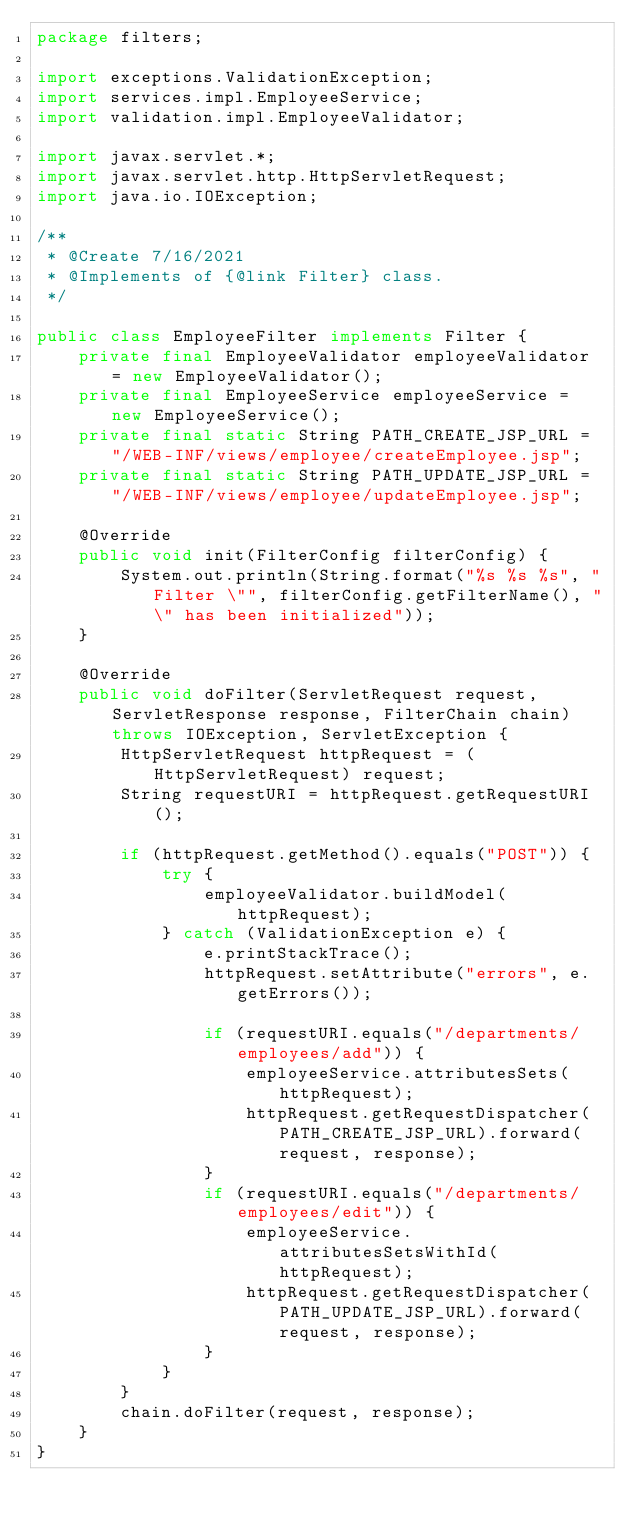<code> <loc_0><loc_0><loc_500><loc_500><_Java_>package filters;

import exceptions.ValidationException;
import services.impl.EmployeeService;
import validation.impl.EmployeeValidator;

import javax.servlet.*;
import javax.servlet.http.HttpServletRequest;
import java.io.IOException;

/**
 * @Create 7/16/2021
 * @Implements of {@link Filter} class.
 */

public class EmployeeFilter implements Filter {
    private final EmployeeValidator employeeValidator = new EmployeeValidator();
    private final EmployeeService employeeService = new EmployeeService();
    private final static String PATH_CREATE_JSP_URL = "/WEB-INF/views/employee/createEmployee.jsp";
    private final static String PATH_UPDATE_JSP_URL = "/WEB-INF/views/employee/updateEmployee.jsp";

    @Override
    public void init(FilterConfig filterConfig) {
        System.out.println(String.format("%s %s %s", "Filter \"", filterConfig.getFilterName(), "\" has been initialized"));
    }

    @Override
    public void doFilter(ServletRequest request, ServletResponse response, FilterChain chain) throws IOException, ServletException {
        HttpServletRequest httpRequest = (HttpServletRequest) request;
        String requestURI = httpRequest.getRequestURI();

        if (httpRequest.getMethod().equals("POST")) {
            try {
                employeeValidator.buildModel(httpRequest);
            } catch (ValidationException e) {
                e.printStackTrace();
                httpRequest.setAttribute("errors", e.getErrors());

                if (requestURI.equals("/departments/employees/add")) {
                    employeeService.attributesSets(httpRequest);
                    httpRequest.getRequestDispatcher(PATH_CREATE_JSP_URL).forward(request, response);
                }
                if (requestURI.equals("/departments/employees/edit")) {
                    employeeService.attributesSetsWithId(httpRequest);
                    httpRequest.getRequestDispatcher(PATH_UPDATE_JSP_URL).forward(request, response);
                }
            }
        }
        chain.doFilter(request, response);
    }
}</code> 